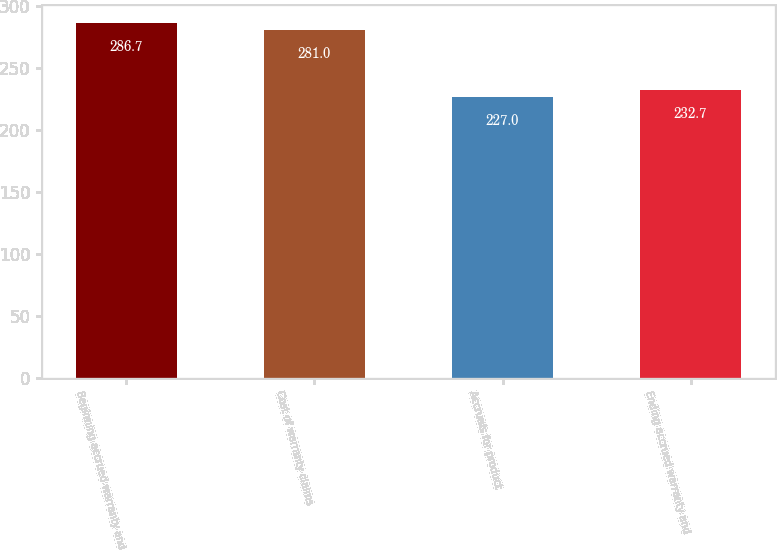<chart> <loc_0><loc_0><loc_500><loc_500><bar_chart><fcel>Beginning accrued warranty and<fcel>Cost of warranty claims<fcel>Accruals for product<fcel>Ending accrued warranty and<nl><fcel>286.7<fcel>281<fcel>227<fcel>232.7<nl></chart> 